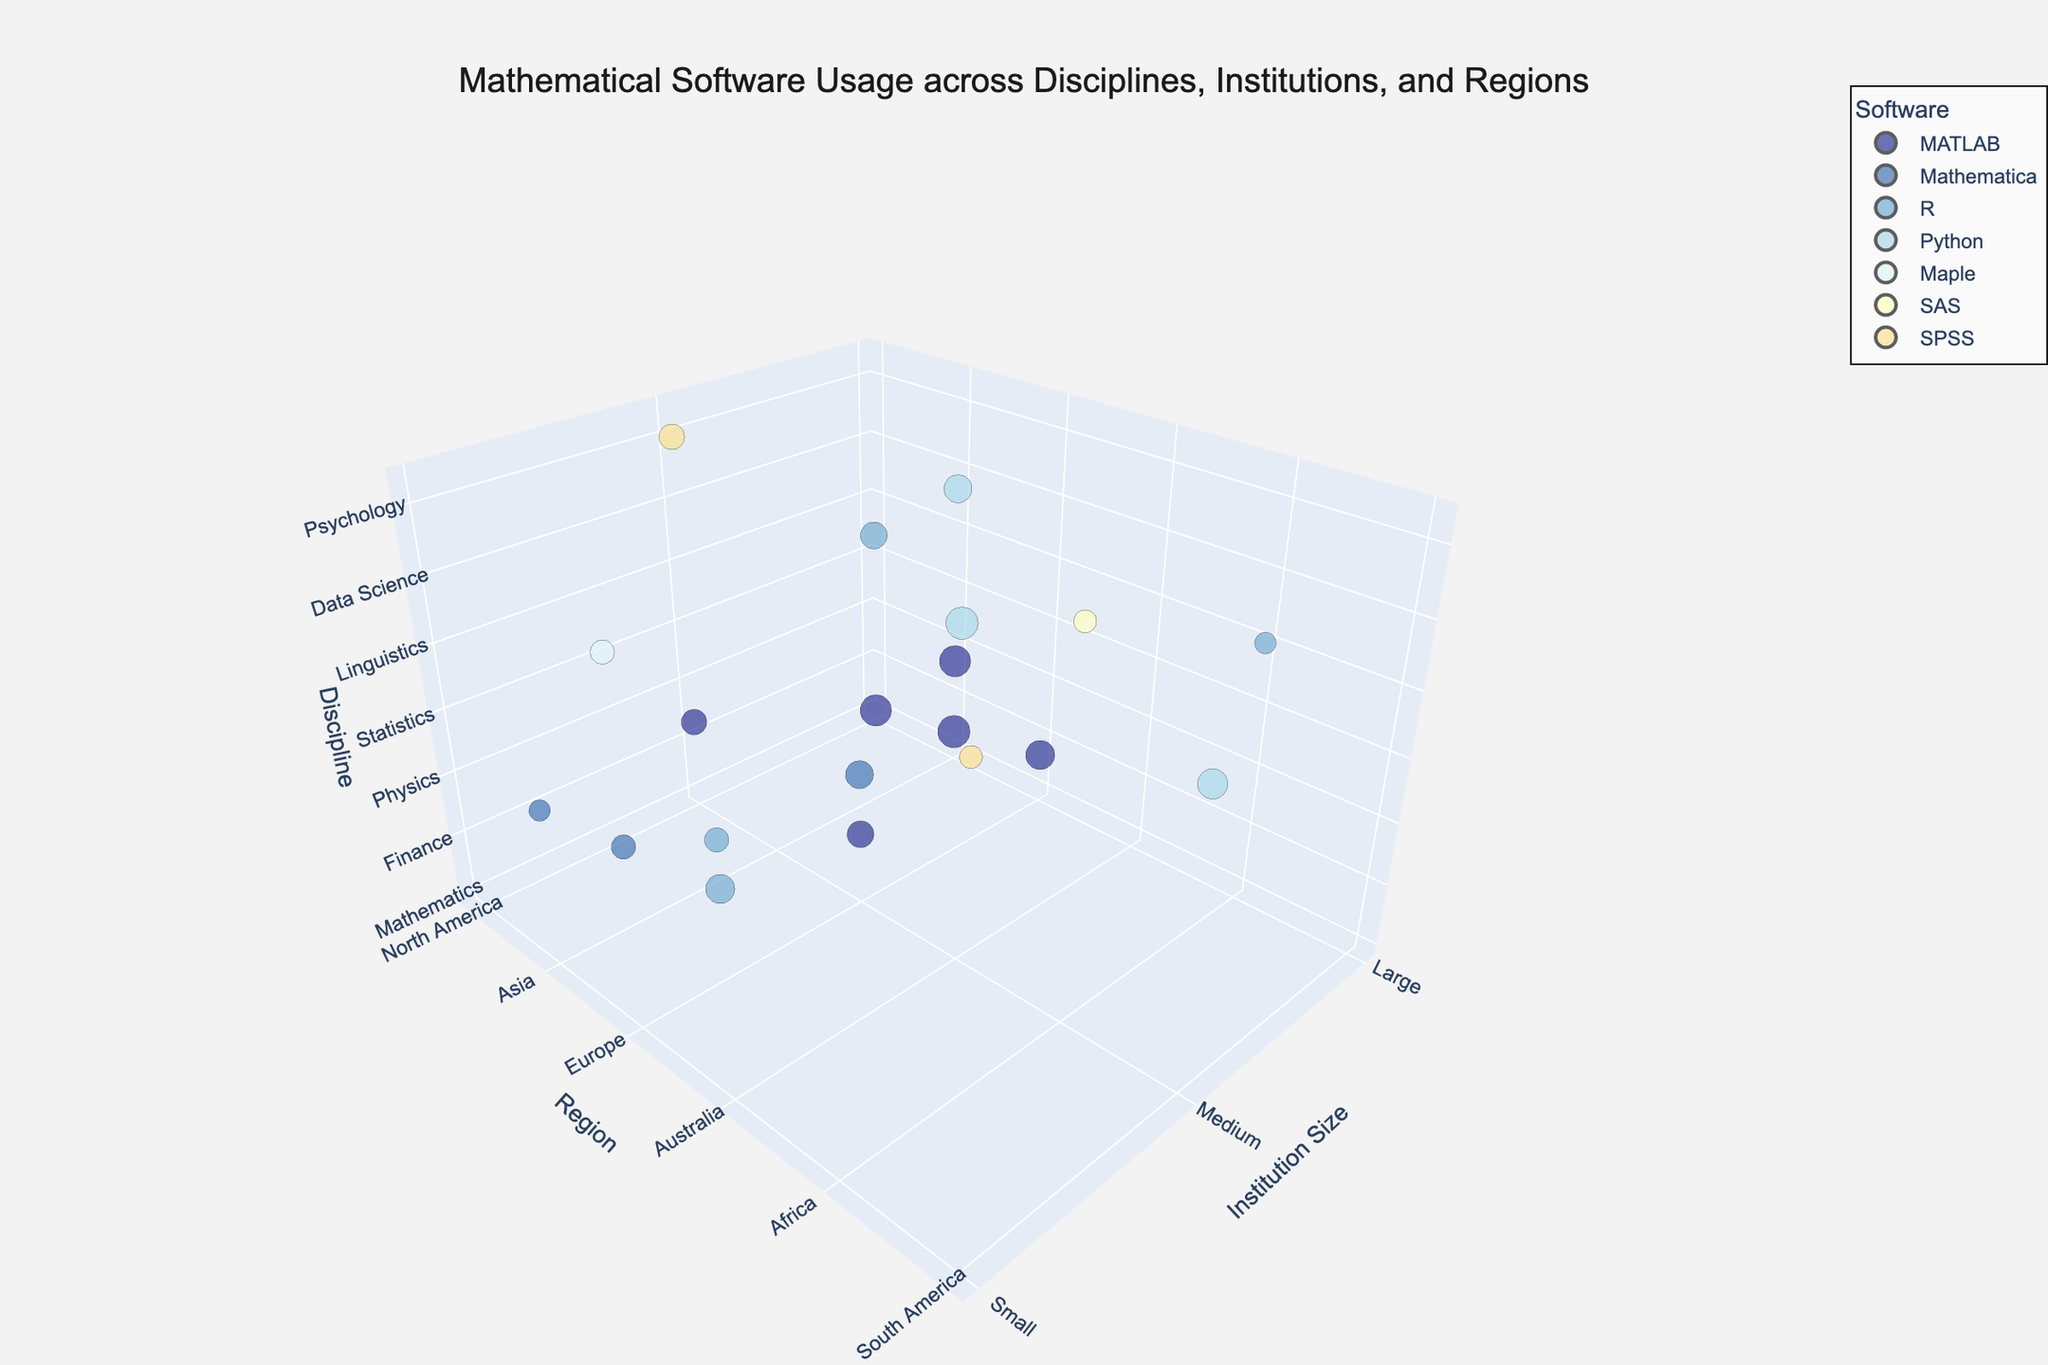What is the title of the plot? The title of a plot is usually displayed at the top of the chart. In this specific plot, it says "Mathematical Software Usage across Disciplines, Institutions, and Regions."
Answer: Mathematical Software Usage across Disciplines, Institutions, and Regions Which software shows the highest usage in Mathematics? First, locate Mathematics in the Discipline axis, then look at the bubbles and check the hover names. Identify the one with the highest usage percentage. MATLAB is the software used 75%, the highest among all.
Answer: MATLAB Which region shows the highest usage of Python? Identify the bubbles with the 'Python' hover name, then find the one with the largest size (Usage Percentage) and check the Region axis. The bubble for Computer Science in South America with 70% usage, and Data Science in Australia with 80% usage are contenders, hence Australia is the highest.
Answer: Australia How many disciplines use MATLAB in large institutions? Find bubbles where 'MATLAB' appears in the hover name and where the Institution Size is classified as 'Large'. Count these bubbles: Mathematics, Engineering, Astronomy, Electrical Engineering, total four.
Answer: 4 What percentage of Sociology in South America uses SPSS? Locate the discipline Sociology and the region South America. Check the bubble size (Usage Percentage) and hover name for SPSS. The usage percentage displayed is 40%.
Answer: 40% Which disciplines in North America use MATLAB? Look at the bubbles where the Region axis indicates North America, find the ones showing 'MATLAB' in the hover name, then check the Discipline axis. It is Oceanography.
Answer: Oceanography Compared to Biology in Africa, which disciplines have a higher usage percentage of their respective software? Identify the bubble for Biology in Africa, which shows SAS with 40%. Then, identify bubbles with usage percentages above 40%. These are: Mathematics (MATLAB, 75%), Engineering (MATLAB, 80%), Computer Science (Python, 70%), Statistics (R, 65%), Economics (R, 55%), Astronomy (MATLAB, 65%), Data Science (Python, 80%).
Answer: Mathematics, Engineering, Computer Science, Statistics, Economics, Astronomy, Data Science Which region has the lowest usage of Mathematica? Identify the bubbles in the plot with 'Mathematica' in their hover names. Compare their usage percentages. Among them, Geology in Asia has the lowest with 35%.
Answer: Asia How many small institutions use the software R? Find the bubbles where the software hover name is 'R' and the Institution Size on the x-axis is 'Small'. Count the bubbles: Statistics in Australia, Environmental Science in Australia, both totaling two.
Answer: 2 What is the average usage percentage of MATLAB across all regions? Identify all bubbles where MATLAB is listed in the hover name, sum their usage percentages, and divide by the number of such bubbles. Usage: Mathematics (75), Engineering (80), Astronomy (65), Electrical Engineering (75), Oceanography (50). Sum is 345, divided by 5 gives us 69.
Answer: 69 